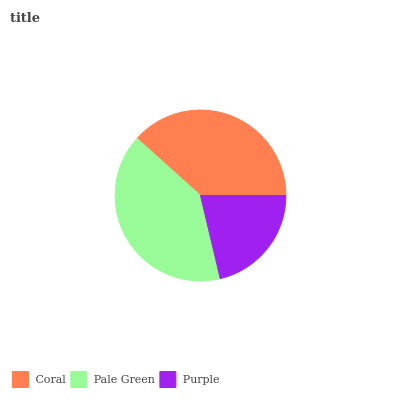Is Purple the minimum?
Answer yes or no. Yes. Is Pale Green the maximum?
Answer yes or no. Yes. Is Pale Green the minimum?
Answer yes or no. No. Is Purple the maximum?
Answer yes or no. No. Is Pale Green greater than Purple?
Answer yes or no. Yes. Is Purple less than Pale Green?
Answer yes or no. Yes. Is Purple greater than Pale Green?
Answer yes or no. No. Is Pale Green less than Purple?
Answer yes or no. No. Is Coral the high median?
Answer yes or no. Yes. Is Coral the low median?
Answer yes or no. Yes. Is Pale Green the high median?
Answer yes or no. No. Is Pale Green the low median?
Answer yes or no. No. 